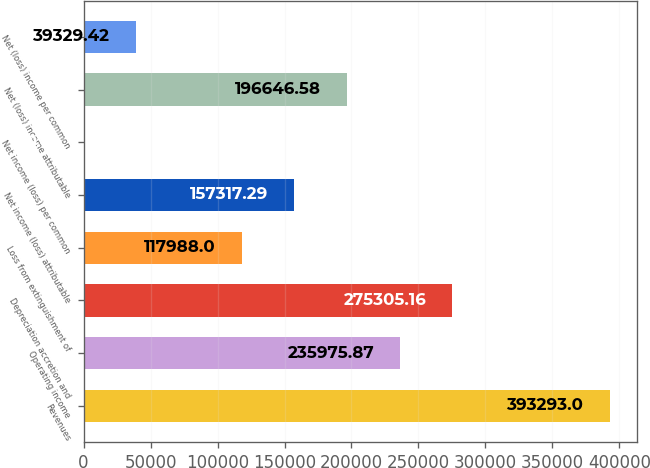Convert chart to OTSL. <chart><loc_0><loc_0><loc_500><loc_500><bar_chart><fcel>Revenues<fcel>Operating income<fcel>Depreciation accretion and<fcel>Loss from extinguishment of<fcel>Net income (loss) attributable<fcel>Net income (loss) per common<fcel>Net (loss) income attributable<fcel>Net (loss) income per common<nl><fcel>393293<fcel>235976<fcel>275305<fcel>117988<fcel>157317<fcel>0.13<fcel>196647<fcel>39329.4<nl></chart> 